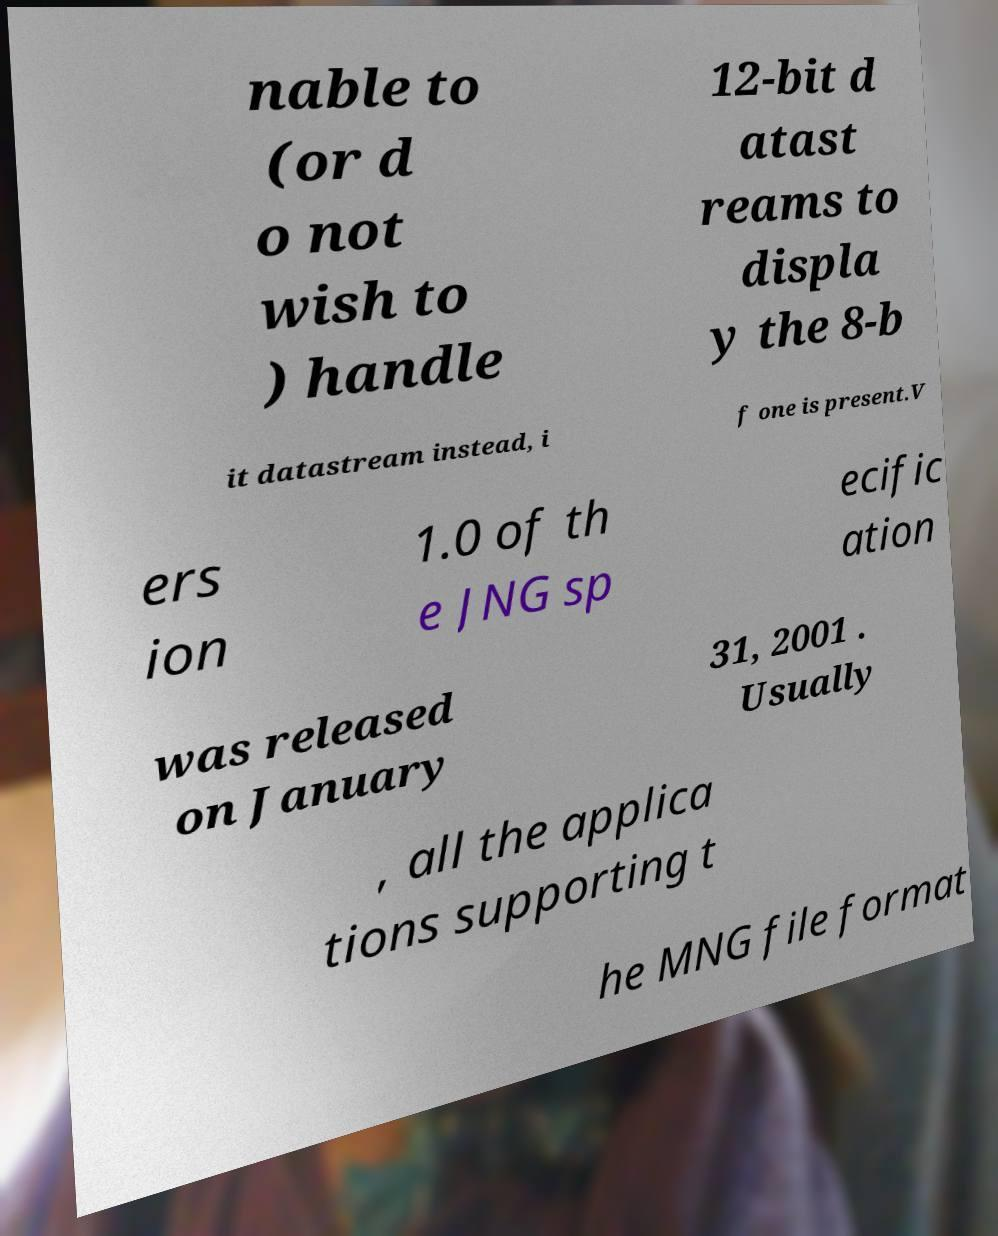There's text embedded in this image that I need extracted. Can you transcribe it verbatim? nable to (or d o not wish to ) handle 12-bit d atast reams to displa y the 8-b it datastream instead, i f one is present.V ers ion 1.0 of th e JNG sp ecific ation was released on January 31, 2001 . Usually , all the applica tions supporting t he MNG file format 